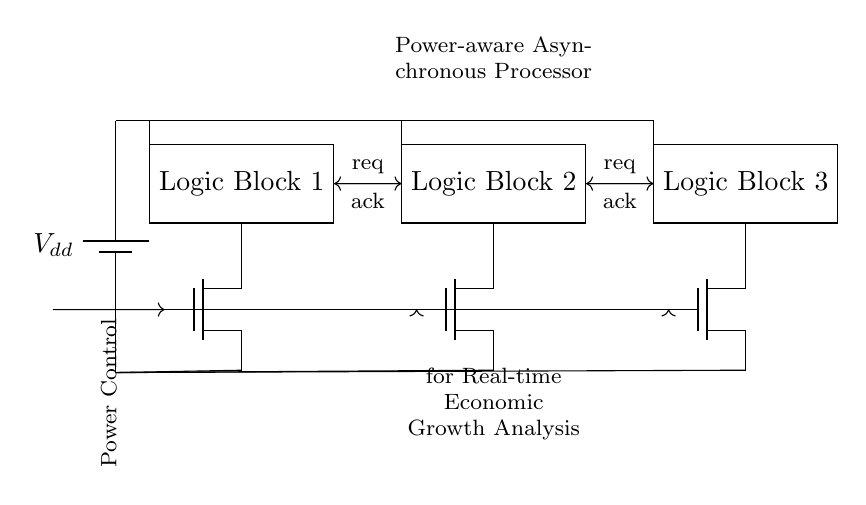What is the type of power supply used in this circuit? The circuit uses a battery as the power source, indicated by the "battery1" symbol at the top left corner. This symbol represents a voltage source.
Answer: Battery How many asynchronous logic blocks are present? There are three asynchronous logic blocks in the circuit diagram, labeled as Logic Block 1, Logic Block 2, and Logic Block 3. Each is represented by a rectangle with its respective label.
Answer: Three What kind of transistors are used for power gating? The circuit diagram shows NMOS transistors, as denoted by the symbol “nmos” in the diagram located below each logic block, which indicates the type of transistor used.
Answer: NMOS What signals are exchanged between Logic Block 1 and Logic Block 2? Logic Block 1 and Logic Block 2 exchange “req” (request) and “ack” (acknowledgment) signals, as shown by the arrows and labels connecting the two blocks. This indicates the handshake mechanism for communication.
Answer: Req and ack What is the overall function of the circuit represented? This circuit is designed as a power-aware asynchronous processor for real-time economic growth analysis, as stated in the label at the top center of the diagram, indicating its purpose and context.
Answer: Real-time economic growth analysis How are the power control signals connected to the NMOS transistors? The power control signals are indicated by arrows pointing from the left side of the diagram to the gate terminals of each NMOS transistor. This represents the control mechanism for powering the logic blocks.
Answer: Through arrows to the gates 